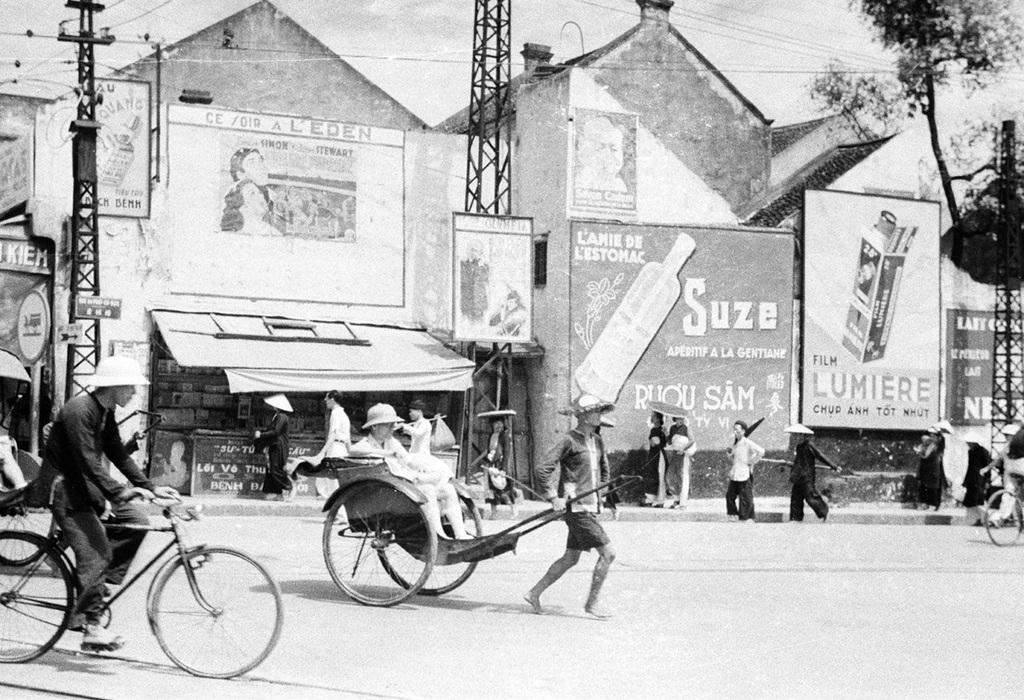What can be seen in the background of the image? The sky is visible in the image. What object is present near the edge of the image? There is a current pole in the image. What type of building is in the image? There is a house in the image. What additional feature is present in the image? There is a banner in the image. Are there any people in the image? Yes, there are people present in the image. What activity is a man performing on the left side of the image? A man is riding a bicycle on the left side of the image. What type of establishment is in the image? There is a shop in the image. What type of rice is being served in the prison depicted in the image? There is no prison or rice present in the image; it features a house, a shop, a banner, a man on a bicycle, and people. How many people have died in the image? There is no indication of death or any deceased individuals in the image. 